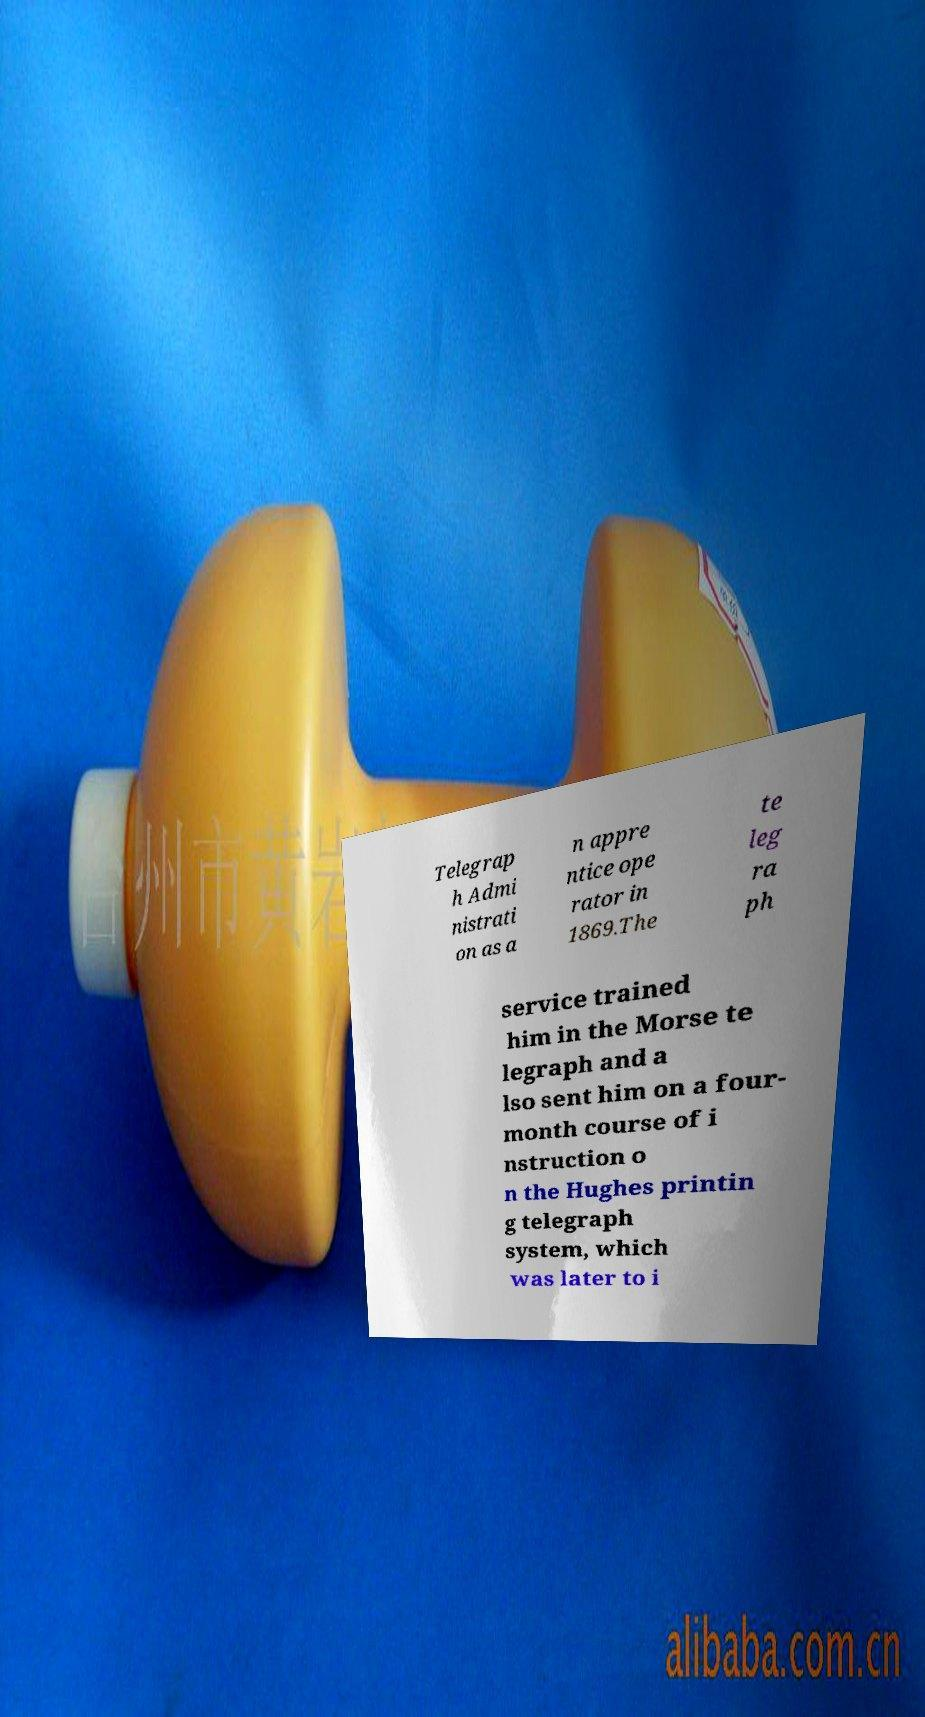For documentation purposes, I need the text within this image transcribed. Could you provide that? Telegrap h Admi nistrati on as a n appre ntice ope rator in 1869.The te leg ra ph service trained him in the Morse te legraph and a lso sent him on a four- month course of i nstruction o n the Hughes printin g telegraph system, which was later to i 